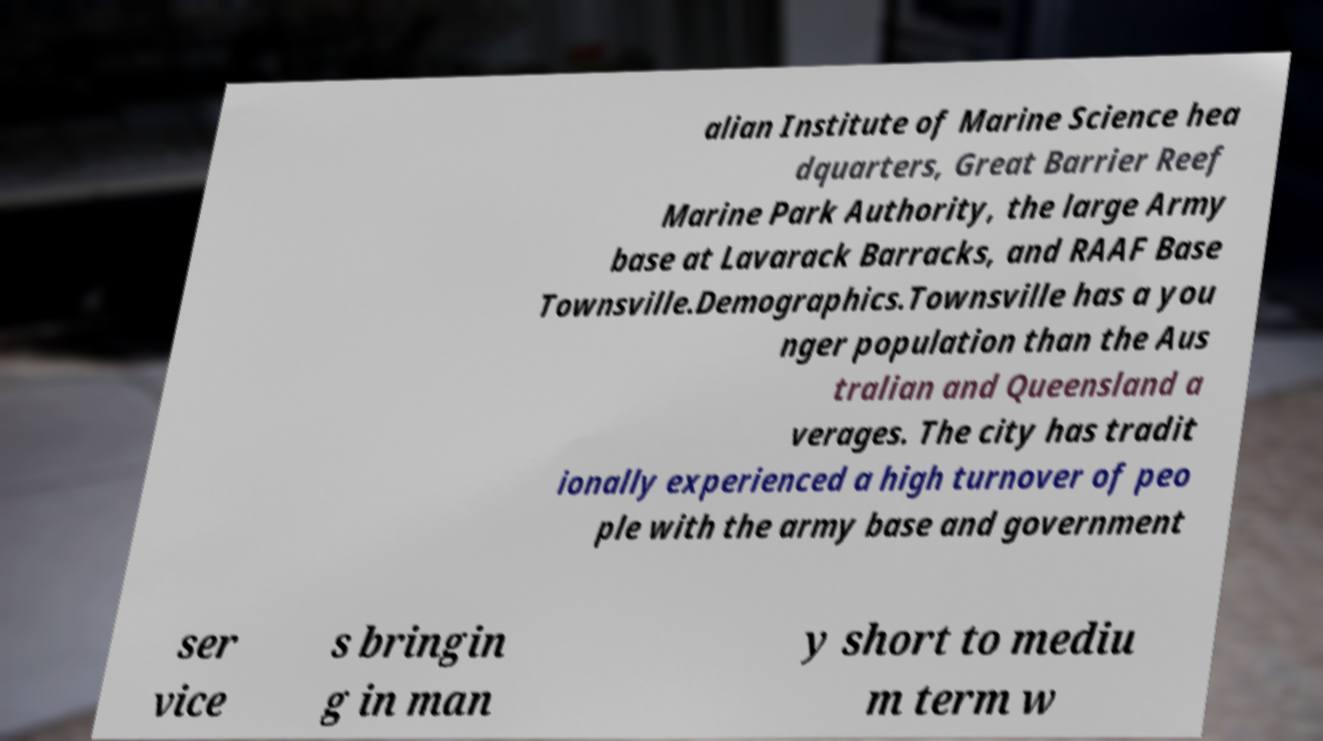Can you accurately transcribe the text from the provided image for me? alian Institute of Marine Science hea dquarters, Great Barrier Reef Marine Park Authority, the large Army base at Lavarack Barracks, and RAAF Base Townsville.Demographics.Townsville has a you nger population than the Aus tralian and Queensland a verages. The city has tradit ionally experienced a high turnover of peo ple with the army base and government ser vice s bringin g in man y short to mediu m term w 